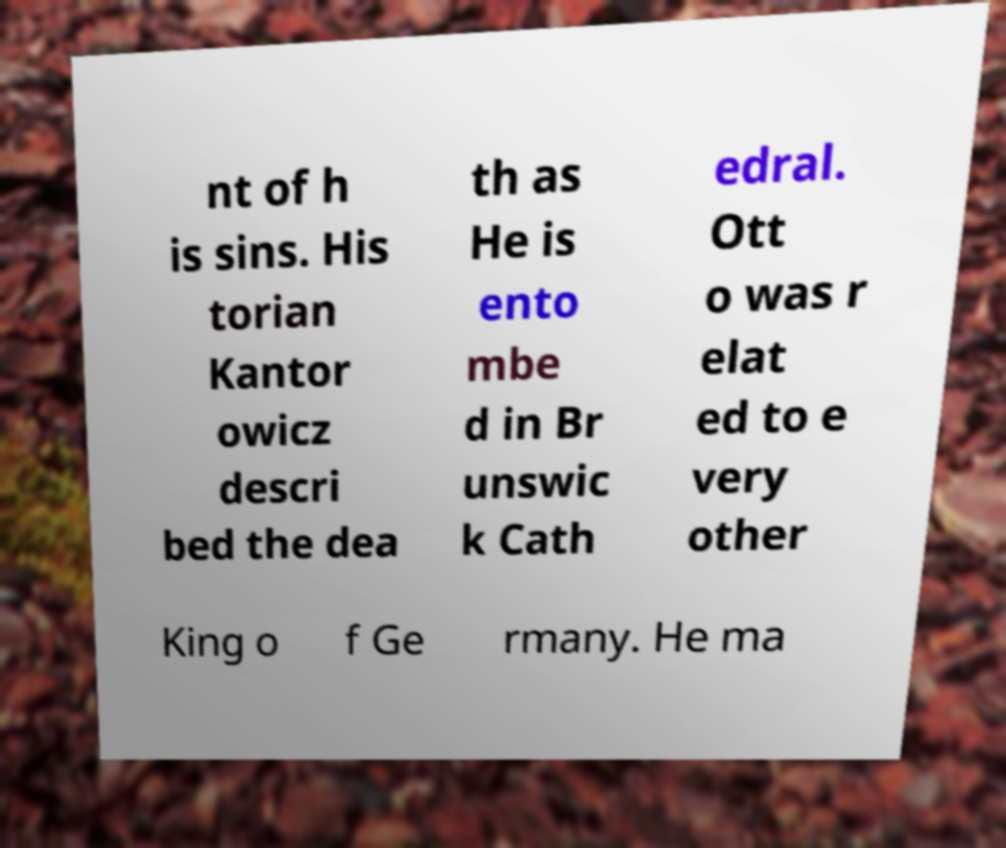For documentation purposes, I need the text within this image transcribed. Could you provide that? nt of h is sins. His torian Kantor owicz descri bed the dea th as He is ento mbe d in Br unswic k Cath edral. Ott o was r elat ed to e very other King o f Ge rmany. He ma 